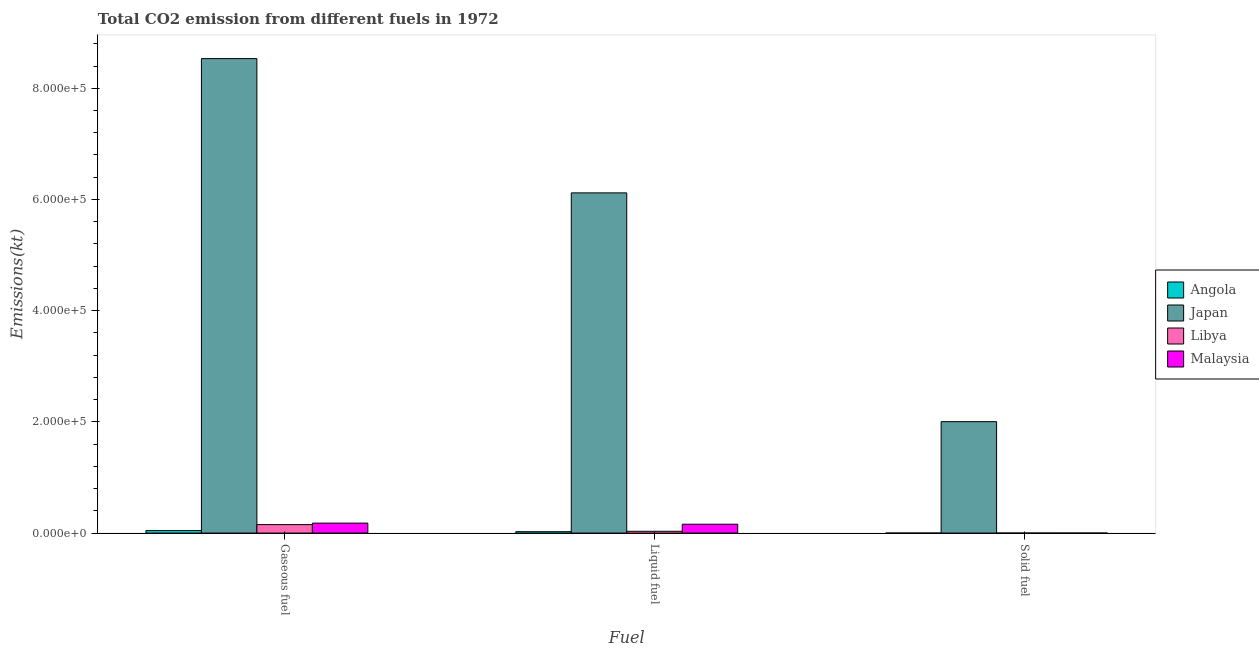Are the number of bars per tick equal to the number of legend labels?
Keep it short and to the point. Yes. How many bars are there on the 3rd tick from the right?
Provide a succinct answer. 4. What is the label of the 3rd group of bars from the left?
Your answer should be very brief. Solid fuel. What is the amount of co2 emissions from solid fuel in Japan?
Provide a succinct answer. 2.00e+05. Across all countries, what is the maximum amount of co2 emissions from liquid fuel?
Your answer should be very brief. 6.12e+05. Across all countries, what is the minimum amount of co2 emissions from liquid fuel?
Provide a short and direct response. 2478.89. In which country was the amount of co2 emissions from liquid fuel minimum?
Keep it short and to the point. Angola. What is the total amount of co2 emissions from gaseous fuel in the graph?
Ensure brevity in your answer.  8.91e+05. What is the difference between the amount of co2 emissions from solid fuel in Libya and that in Japan?
Offer a terse response. -2.00e+05. What is the difference between the amount of co2 emissions from gaseous fuel in Libya and the amount of co2 emissions from liquid fuel in Angola?
Make the answer very short. 1.28e+04. What is the average amount of co2 emissions from gaseous fuel per country?
Make the answer very short. 2.23e+05. What is the difference between the amount of co2 emissions from liquid fuel and amount of co2 emissions from gaseous fuel in Malaysia?
Offer a very short reply. -1987.51. What is the ratio of the amount of co2 emissions from gaseous fuel in Angola to that in Japan?
Ensure brevity in your answer.  0.01. What is the difference between the highest and the second highest amount of co2 emissions from solid fuel?
Your answer should be very brief. 2.00e+05. What is the difference between the highest and the lowest amount of co2 emissions from solid fuel?
Provide a succinct answer. 2.00e+05. What does the 1st bar from the left in Gaseous fuel represents?
Provide a short and direct response. Angola. What does the 4th bar from the right in Gaseous fuel represents?
Provide a short and direct response. Angola. How many countries are there in the graph?
Provide a short and direct response. 4. What is the difference between two consecutive major ticks on the Y-axis?
Keep it short and to the point. 2.00e+05. Are the values on the major ticks of Y-axis written in scientific E-notation?
Provide a short and direct response. Yes. Does the graph contain any zero values?
Your answer should be compact. No. Does the graph contain grids?
Make the answer very short. No. How many legend labels are there?
Ensure brevity in your answer.  4. How are the legend labels stacked?
Make the answer very short. Vertical. What is the title of the graph?
Offer a terse response. Total CO2 emission from different fuels in 1972. What is the label or title of the X-axis?
Your answer should be very brief. Fuel. What is the label or title of the Y-axis?
Provide a short and direct response. Emissions(kt). What is the Emissions(kt) in Angola in Gaseous fuel?
Provide a succinct answer. 4506.74. What is the Emissions(kt) in Japan in Gaseous fuel?
Offer a very short reply. 8.53e+05. What is the Emissions(kt) of Libya in Gaseous fuel?
Ensure brevity in your answer.  1.52e+04. What is the Emissions(kt) of Malaysia in Gaseous fuel?
Give a very brief answer. 1.79e+04. What is the Emissions(kt) of Angola in Liquid fuel?
Keep it short and to the point. 2478.89. What is the Emissions(kt) in Japan in Liquid fuel?
Give a very brief answer. 6.12e+05. What is the Emissions(kt) in Libya in Liquid fuel?
Offer a very short reply. 3197.62. What is the Emissions(kt) in Malaysia in Liquid fuel?
Give a very brief answer. 1.59e+04. What is the Emissions(kt) of Angola in Solid fuel?
Offer a very short reply. 7.33. What is the Emissions(kt) of Japan in Solid fuel?
Your answer should be compact. 2.00e+05. What is the Emissions(kt) of Libya in Solid fuel?
Your answer should be very brief. 3.67. What is the Emissions(kt) in Malaysia in Solid fuel?
Provide a succinct answer. 33. Across all Fuel, what is the maximum Emissions(kt) of Angola?
Your response must be concise. 4506.74. Across all Fuel, what is the maximum Emissions(kt) of Japan?
Your answer should be compact. 8.53e+05. Across all Fuel, what is the maximum Emissions(kt) in Libya?
Ensure brevity in your answer.  1.52e+04. Across all Fuel, what is the maximum Emissions(kt) in Malaysia?
Ensure brevity in your answer.  1.79e+04. Across all Fuel, what is the minimum Emissions(kt) of Angola?
Ensure brevity in your answer.  7.33. Across all Fuel, what is the minimum Emissions(kt) of Japan?
Provide a succinct answer. 2.00e+05. Across all Fuel, what is the minimum Emissions(kt) of Libya?
Ensure brevity in your answer.  3.67. Across all Fuel, what is the minimum Emissions(kt) in Malaysia?
Ensure brevity in your answer.  33. What is the total Emissions(kt) of Angola in the graph?
Your answer should be very brief. 6992.97. What is the total Emissions(kt) of Japan in the graph?
Make the answer very short. 1.67e+06. What is the total Emissions(kt) in Libya in the graph?
Make the answer very short. 1.84e+04. What is the total Emissions(kt) of Malaysia in the graph?
Keep it short and to the point. 3.39e+04. What is the difference between the Emissions(kt) in Angola in Gaseous fuel and that in Liquid fuel?
Offer a very short reply. 2027.85. What is the difference between the Emissions(kt) in Japan in Gaseous fuel and that in Liquid fuel?
Your answer should be very brief. 2.42e+05. What is the difference between the Emissions(kt) of Libya in Gaseous fuel and that in Liquid fuel?
Ensure brevity in your answer.  1.20e+04. What is the difference between the Emissions(kt) of Malaysia in Gaseous fuel and that in Liquid fuel?
Your response must be concise. 1987.51. What is the difference between the Emissions(kt) of Angola in Gaseous fuel and that in Solid fuel?
Offer a very short reply. 4499.41. What is the difference between the Emissions(kt) of Japan in Gaseous fuel and that in Solid fuel?
Provide a short and direct response. 6.53e+05. What is the difference between the Emissions(kt) in Libya in Gaseous fuel and that in Solid fuel?
Keep it short and to the point. 1.52e+04. What is the difference between the Emissions(kt) in Malaysia in Gaseous fuel and that in Solid fuel?
Offer a terse response. 1.79e+04. What is the difference between the Emissions(kt) in Angola in Liquid fuel and that in Solid fuel?
Make the answer very short. 2471.56. What is the difference between the Emissions(kt) of Japan in Liquid fuel and that in Solid fuel?
Offer a very short reply. 4.11e+05. What is the difference between the Emissions(kt) in Libya in Liquid fuel and that in Solid fuel?
Make the answer very short. 3193.96. What is the difference between the Emissions(kt) of Malaysia in Liquid fuel and that in Solid fuel?
Make the answer very short. 1.59e+04. What is the difference between the Emissions(kt) in Angola in Gaseous fuel and the Emissions(kt) in Japan in Liquid fuel?
Your response must be concise. -6.07e+05. What is the difference between the Emissions(kt) in Angola in Gaseous fuel and the Emissions(kt) in Libya in Liquid fuel?
Offer a terse response. 1309.12. What is the difference between the Emissions(kt) in Angola in Gaseous fuel and the Emissions(kt) in Malaysia in Liquid fuel?
Provide a succinct answer. -1.14e+04. What is the difference between the Emissions(kt) in Japan in Gaseous fuel and the Emissions(kt) in Libya in Liquid fuel?
Your response must be concise. 8.50e+05. What is the difference between the Emissions(kt) of Japan in Gaseous fuel and the Emissions(kt) of Malaysia in Liquid fuel?
Keep it short and to the point. 8.37e+05. What is the difference between the Emissions(kt) of Libya in Gaseous fuel and the Emissions(kt) of Malaysia in Liquid fuel?
Give a very brief answer. -693.06. What is the difference between the Emissions(kt) of Angola in Gaseous fuel and the Emissions(kt) of Japan in Solid fuel?
Give a very brief answer. -1.96e+05. What is the difference between the Emissions(kt) of Angola in Gaseous fuel and the Emissions(kt) of Libya in Solid fuel?
Offer a very short reply. 4503.08. What is the difference between the Emissions(kt) in Angola in Gaseous fuel and the Emissions(kt) in Malaysia in Solid fuel?
Your response must be concise. 4473.74. What is the difference between the Emissions(kt) in Japan in Gaseous fuel and the Emissions(kt) in Libya in Solid fuel?
Make the answer very short. 8.53e+05. What is the difference between the Emissions(kt) of Japan in Gaseous fuel and the Emissions(kt) of Malaysia in Solid fuel?
Provide a short and direct response. 8.53e+05. What is the difference between the Emissions(kt) in Libya in Gaseous fuel and the Emissions(kt) in Malaysia in Solid fuel?
Offer a terse response. 1.52e+04. What is the difference between the Emissions(kt) in Angola in Liquid fuel and the Emissions(kt) in Japan in Solid fuel?
Ensure brevity in your answer.  -1.98e+05. What is the difference between the Emissions(kt) of Angola in Liquid fuel and the Emissions(kt) of Libya in Solid fuel?
Make the answer very short. 2475.22. What is the difference between the Emissions(kt) of Angola in Liquid fuel and the Emissions(kt) of Malaysia in Solid fuel?
Your response must be concise. 2445.89. What is the difference between the Emissions(kt) of Japan in Liquid fuel and the Emissions(kt) of Libya in Solid fuel?
Offer a terse response. 6.12e+05. What is the difference between the Emissions(kt) of Japan in Liquid fuel and the Emissions(kt) of Malaysia in Solid fuel?
Provide a succinct answer. 6.12e+05. What is the difference between the Emissions(kt) of Libya in Liquid fuel and the Emissions(kt) of Malaysia in Solid fuel?
Your answer should be very brief. 3164.62. What is the average Emissions(kt) of Angola per Fuel?
Your answer should be compact. 2330.99. What is the average Emissions(kt) of Japan per Fuel?
Give a very brief answer. 5.55e+05. What is the average Emissions(kt) of Libya per Fuel?
Make the answer very short. 6144.67. What is the average Emissions(kt) of Malaysia per Fuel?
Make the answer very short. 1.13e+04. What is the difference between the Emissions(kt) in Angola and Emissions(kt) in Japan in Gaseous fuel?
Keep it short and to the point. -8.49e+05. What is the difference between the Emissions(kt) in Angola and Emissions(kt) in Libya in Gaseous fuel?
Offer a very short reply. -1.07e+04. What is the difference between the Emissions(kt) of Angola and Emissions(kt) of Malaysia in Gaseous fuel?
Keep it short and to the point. -1.34e+04. What is the difference between the Emissions(kt) in Japan and Emissions(kt) in Libya in Gaseous fuel?
Your answer should be compact. 8.38e+05. What is the difference between the Emissions(kt) in Japan and Emissions(kt) in Malaysia in Gaseous fuel?
Provide a short and direct response. 8.35e+05. What is the difference between the Emissions(kt) of Libya and Emissions(kt) of Malaysia in Gaseous fuel?
Ensure brevity in your answer.  -2680.58. What is the difference between the Emissions(kt) of Angola and Emissions(kt) of Japan in Liquid fuel?
Offer a terse response. -6.09e+05. What is the difference between the Emissions(kt) in Angola and Emissions(kt) in Libya in Liquid fuel?
Ensure brevity in your answer.  -718.73. What is the difference between the Emissions(kt) of Angola and Emissions(kt) of Malaysia in Liquid fuel?
Keep it short and to the point. -1.34e+04. What is the difference between the Emissions(kt) in Japan and Emissions(kt) in Libya in Liquid fuel?
Offer a terse response. 6.09e+05. What is the difference between the Emissions(kt) of Japan and Emissions(kt) of Malaysia in Liquid fuel?
Provide a succinct answer. 5.96e+05. What is the difference between the Emissions(kt) in Libya and Emissions(kt) in Malaysia in Liquid fuel?
Give a very brief answer. -1.27e+04. What is the difference between the Emissions(kt) in Angola and Emissions(kt) in Japan in Solid fuel?
Offer a terse response. -2.00e+05. What is the difference between the Emissions(kt) of Angola and Emissions(kt) of Libya in Solid fuel?
Your answer should be very brief. 3.67. What is the difference between the Emissions(kt) of Angola and Emissions(kt) of Malaysia in Solid fuel?
Make the answer very short. -25.67. What is the difference between the Emissions(kt) of Japan and Emissions(kt) of Libya in Solid fuel?
Provide a short and direct response. 2.00e+05. What is the difference between the Emissions(kt) of Japan and Emissions(kt) of Malaysia in Solid fuel?
Ensure brevity in your answer.  2.00e+05. What is the difference between the Emissions(kt) of Libya and Emissions(kt) of Malaysia in Solid fuel?
Ensure brevity in your answer.  -29.34. What is the ratio of the Emissions(kt) of Angola in Gaseous fuel to that in Liquid fuel?
Keep it short and to the point. 1.82. What is the ratio of the Emissions(kt) of Japan in Gaseous fuel to that in Liquid fuel?
Provide a succinct answer. 1.39. What is the ratio of the Emissions(kt) in Libya in Gaseous fuel to that in Liquid fuel?
Provide a succinct answer. 4.76. What is the ratio of the Emissions(kt) in Malaysia in Gaseous fuel to that in Liquid fuel?
Provide a short and direct response. 1.12. What is the ratio of the Emissions(kt) of Angola in Gaseous fuel to that in Solid fuel?
Provide a short and direct response. 614.5. What is the ratio of the Emissions(kt) of Japan in Gaseous fuel to that in Solid fuel?
Provide a succinct answer. 4.26. What is the ratio of the Emissions(kt) in Libya in Gaseous fuel to that in Solid fuel?
Give a very brief answer. 4154. What is the ratio of the Emissions(kt) of Malaysia in Gaseous fuel to that in Solid fuel?
Your answer should be very brief. 542.78. What is the ratio of the Emissions(kt) of Angola in Liquid fuel to that in Solid fuel?
Provide a short and direct response. 338. What is the ratio of the Emissions(kt) of Japan in Liquid fuel to that in Solid fuel?
Offer a terse response. 3.05. What is the ratio of the Emissions(kt) of Libya in Liquid fuel to that in Solid fuel?
Make the answer very short. 872. What is the ratio of the Emissions(kt) of Malaysia in Liquid fuel to that in Solid fuel?
Your response must be concise. 482.56. What is the difference between the highest and the second highest Emissions(kt) in Angola?
Offer a very short reply. 2027.85. What is the difference between the highest and the second highest Emissions(kt) of Japan?
Your answer should be compact. 2.42e+05. What is the difference between the highest and the second highest Emissions(kt) in Libya?
Offer a terse response. 1.20e+04. What is the difference between the highest and the second highest Emissions(kt) in Malaysia?
Your response must be concise. 1987.51. What is the difference between the highest and the lowest Emissions(kt) of Angola?
Ensure brevity in your answer.  4499.41. What is the difference between the highest and the lowest Emissions(kt) in Japan?
Offer a terse response. 6.53e+05. What is the difference between the highest and the lowest Emissions(kt) of Libya?
Provide a succinct answer. 1.52e+04. What is the difference between the highest and the lowest Emissions(kt) in Malaysia?
Keep it short and to the point. 1.79e+04. 